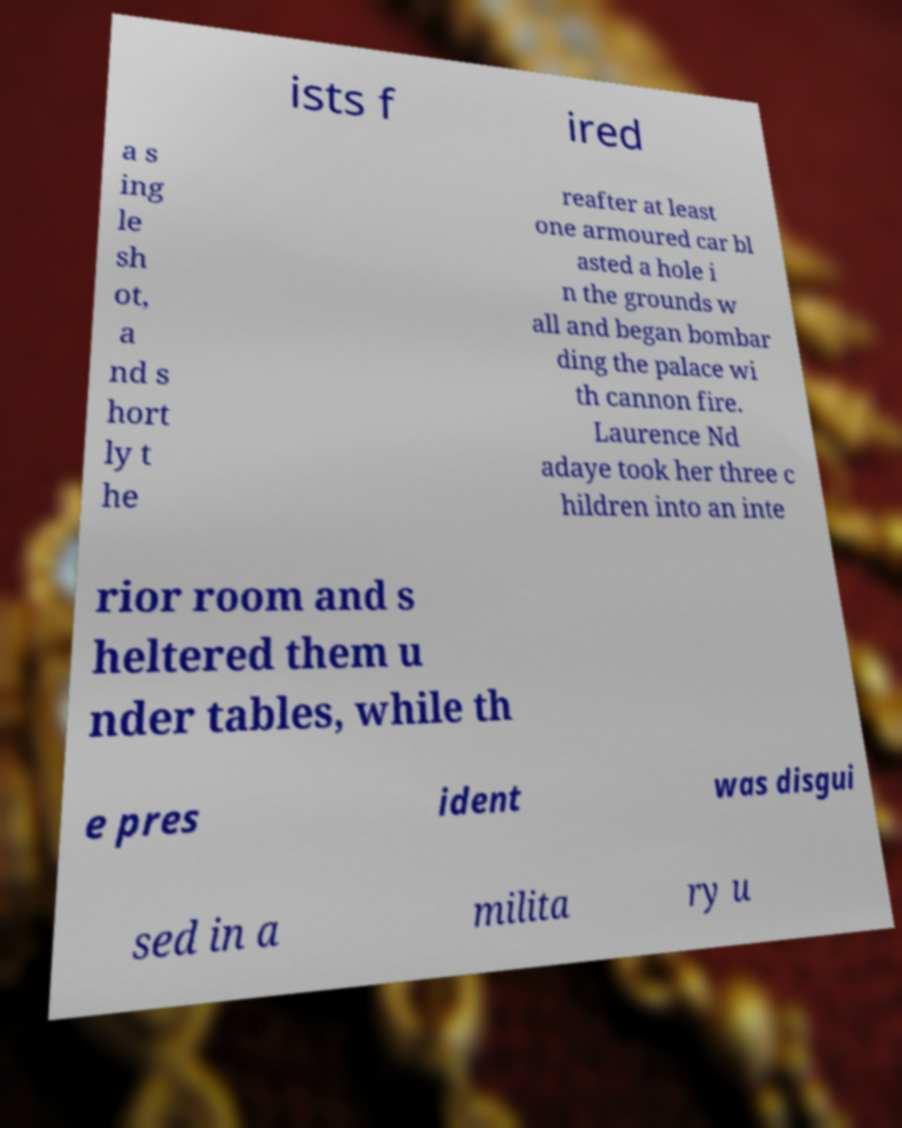Please read and relay the text visible in this image. What does it say? ists f ired a s ing le sh ot, a nd s hort ly t he reafter at least one armoured car bl asted a hole i n the grounds w all and began bombar ding the palace wi th cannon fire. Laurence Nd adaye took her three c hildren into an inte rior room and s heltered them u nder tables, while th e pres ident was disgui sed in a milita ry u 